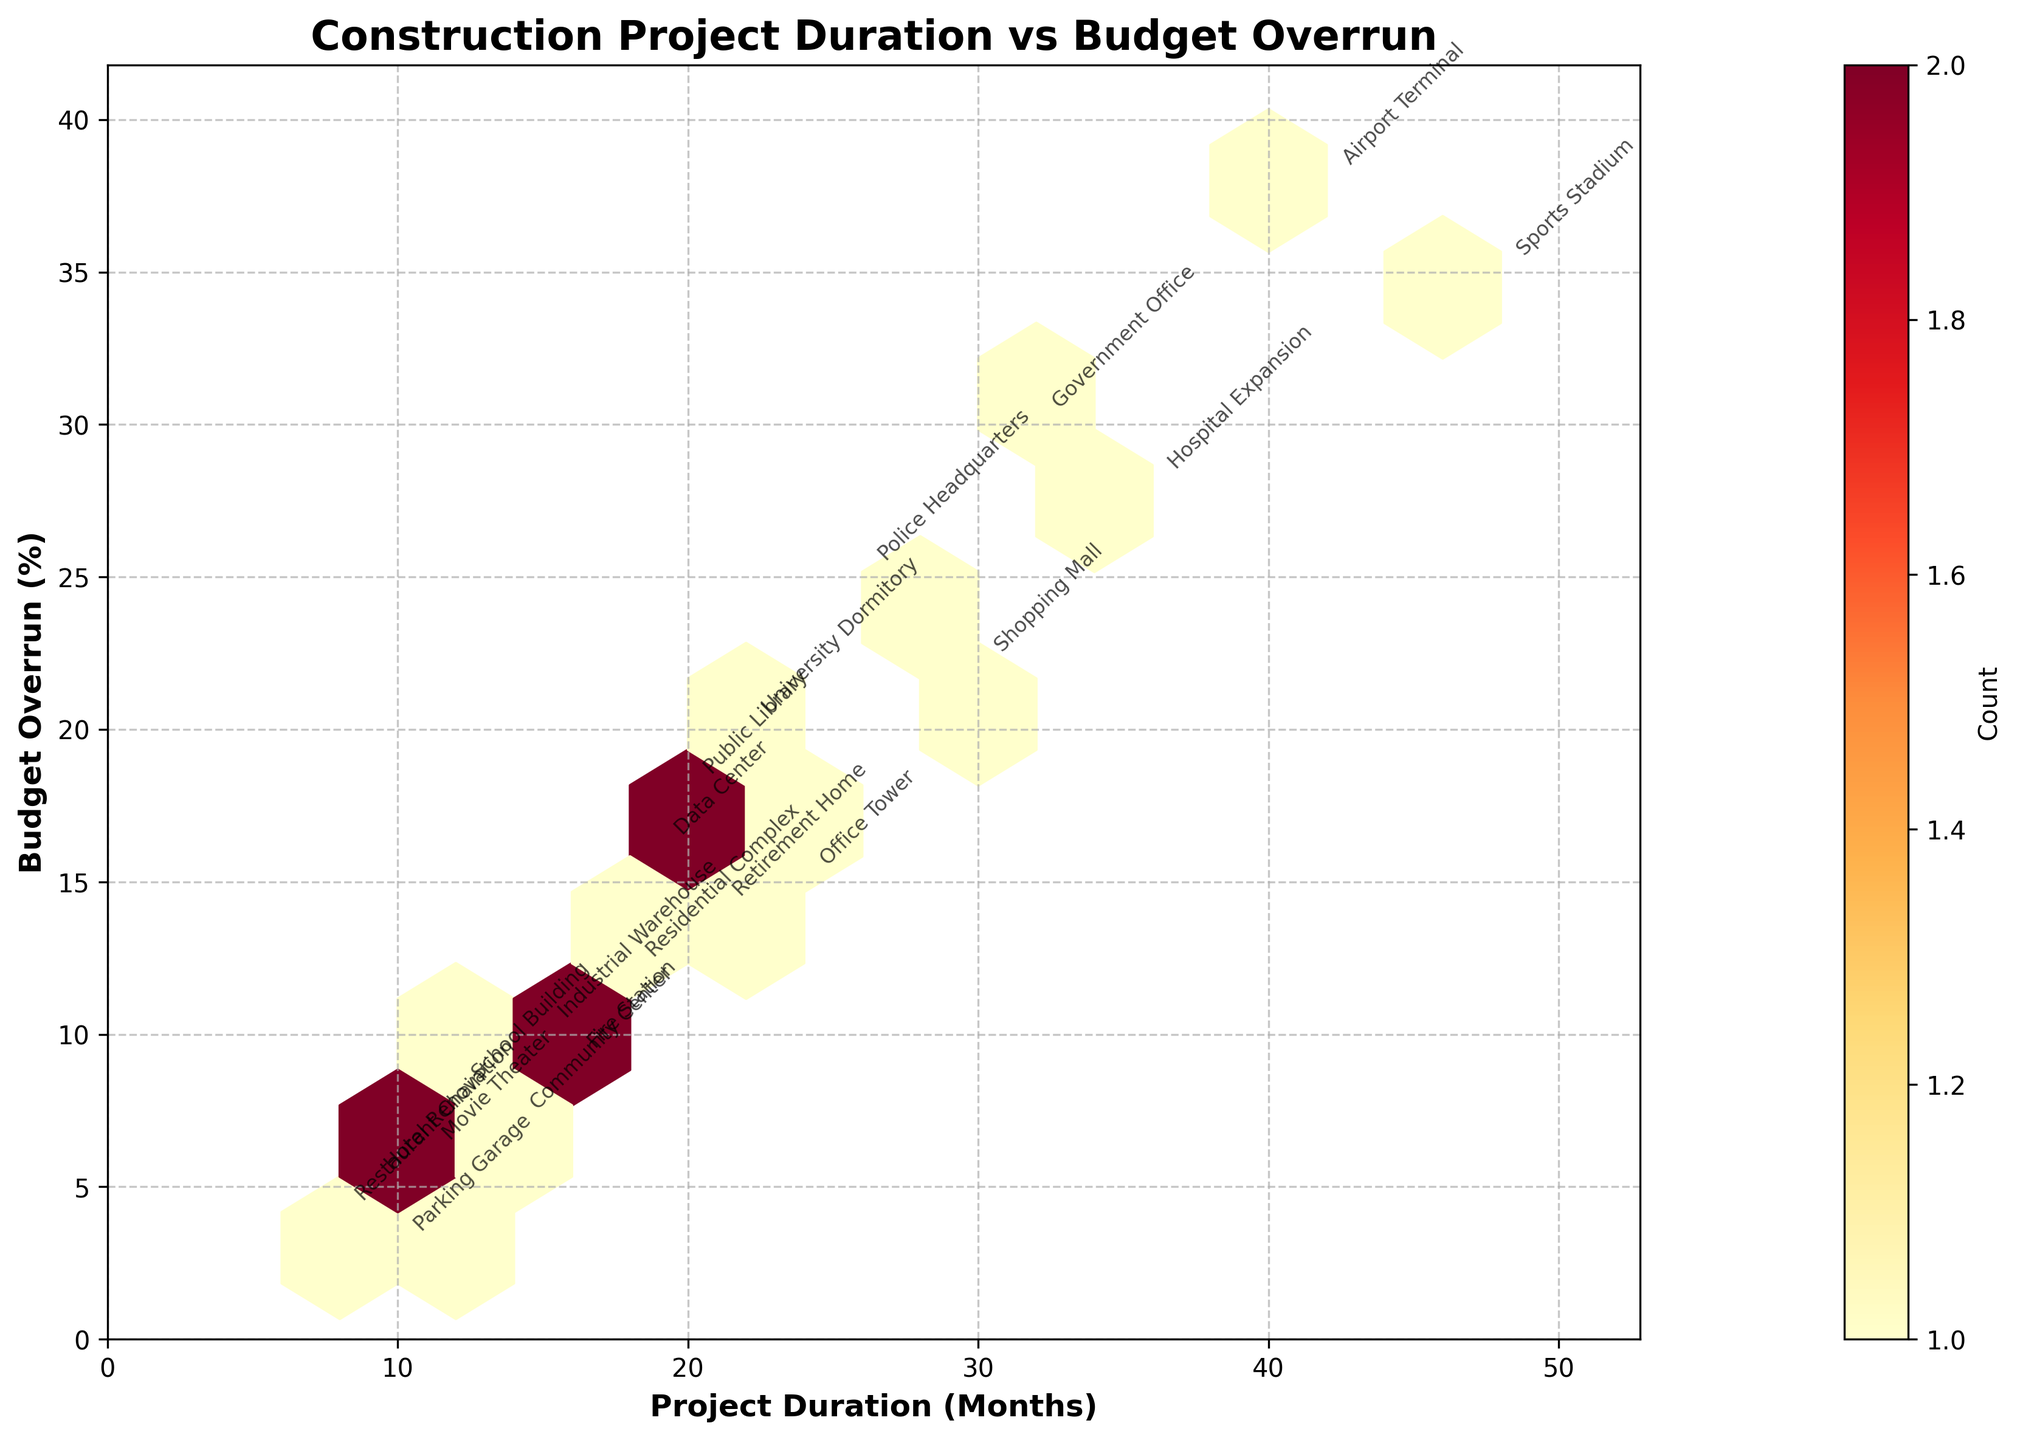What's the title of the plot? The title is located at the top of the plot, providing an overview of the visualized data. The title reads "Construction Project Duration vs Budget Overrun".
Answer: Construction Project Duration vs Budget Overrun What do the x-axis and y-axis represent? The x-axis is labeled "Project Duration (Months)", indicating the time each project takes. The y-axis is labeled "Budget Overrun (%)", showing the percentage by which each project's cost exceeded its budget.
Answer: Project Duration (Months) and Budget Overrun (%) How many hexagons have a count of 1 according to the colorbar? By observing the color gradient and matching it with the colorbar legend, we can see which hexagons are shaded to represent a count of 1. Hexagons with the lightest colors represent a count of 1.
Answer: Several Which project had the longest duration, and what was its budget overrun percentage? The longest project duration can be identified by finding the maximum x-axis value. Here, the "Sports Stadium" project had the longest duration at 48 months, with a budget overrun of 35%.
Answer: Sports Stadium, 35% Is there a noticeable trend between project duration and budget overruns? By observing the scatter pattern of hexagons, we analyze the relationship. A noticeable trend shows that projects with longer durations tend to have higher budget overruns.
Answer: Yes, higher budget overruns correlate with longer durations Which two projects have similar durations but different budget overruns? By comparing points on the x-axis with close values but different positions on the y-axis, we find "Fire Station" and "Residential Complex", both around 16-18 months, but with divergences in budget overruns, 9% and 12% respectively.
Answer: Fire Station and Residential Complex On average, what is more common: higher budget overruns for longer projects or shorter projects? By evaluating the density of hexagons in respective regions, higher concentrations of hexagons in the upper-right quadrant indicate more frequent high budget overruns for longer projects.
Answer: Higher budget overruns for longer projects Which project had the highest budget overrun percentage, and what was its duration? The highest point on the y-axis represents the maximum budget overrun. The "Airport Terminal" project stands out with a 38% budget overrun at a duration of 42 months.
Answer: Airport Terminal, 42 months How does the density of hexagons vary across the plot? Observing the hexagon color gradient, one finds varying densities: higher densities, indicated by darker colors, appear where project durations and budget overruns cluster more frequently.
Answer: Higher densities at clustered regions What is the grid size used in this hexbin plot? The gridsize parameter in the hexbin plot determines the hexagonal bin density; reviewing the plot reveals a gridsize of 10, forming a fine-grained data resolution.
Answer: 10 